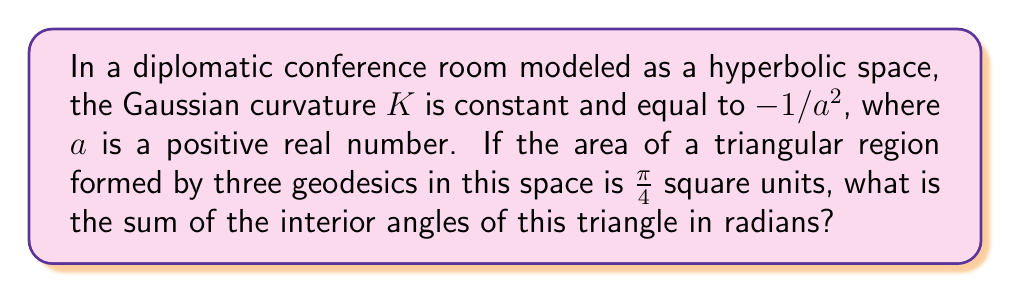Can you answer this question? Let's approach this step-by-step using the principles of hyperbolic geometry:

1) In hyperbolic geometry, the Gauss-Bonnet theorem states that for a triangle with interior angles $\alpha$, $\beta$, and $\gamma$:

   $$A = a^2(\pi - (\alpha + \beta + \gamma))$$

   where $A$ is the area of the triangle and $a$ is the constant from the Gaussian curvature $K = -1/a^2$.

2) We are given that the area of the triangle is $\frac{\pi}{4}$ square units. Let's substitute this into the equation:

   $$\frac{\pi}{4} = a^2(\pi - (\alpha + \beta + \gamma))$$

3) Let's denote the sum of the interior angles as $S = \alpha + \beta + \gamma$. We can rewrite the equation as:

   $$\frac{\pi}{4} = a^2(\pi - S)$$

4) Dividing both sides by $a^2$:

   $$\frac{\pi}{4a^2} = \pi - S$$

5) Solving for $S$:

   $$S = \pi - \frac{\pi}{4a^2}$$

6) Now, recall that the Gaussian curvature $K = -1/a^2$. We can substitute this:

   $$S = \pi - \frac{\pi}{4}(-K) = \pi + \frac{\pi K}{4}$$

7) Given that $K = -1/a^2 = -1$ (since the curvature is constant and equal to $-1/a^2$), we can finally calculate $S$:

   $$S = \pi + \frac{\pi (-1)}{4} = \pi - \frac{\pi}{4} = \frac{3\pi}{4}$$

Thus, the sum of the interior angles of the triangle is $\frac{3\pi}{4}$ radians.
Answer: $\frac{3\pi}{4}$ radians 